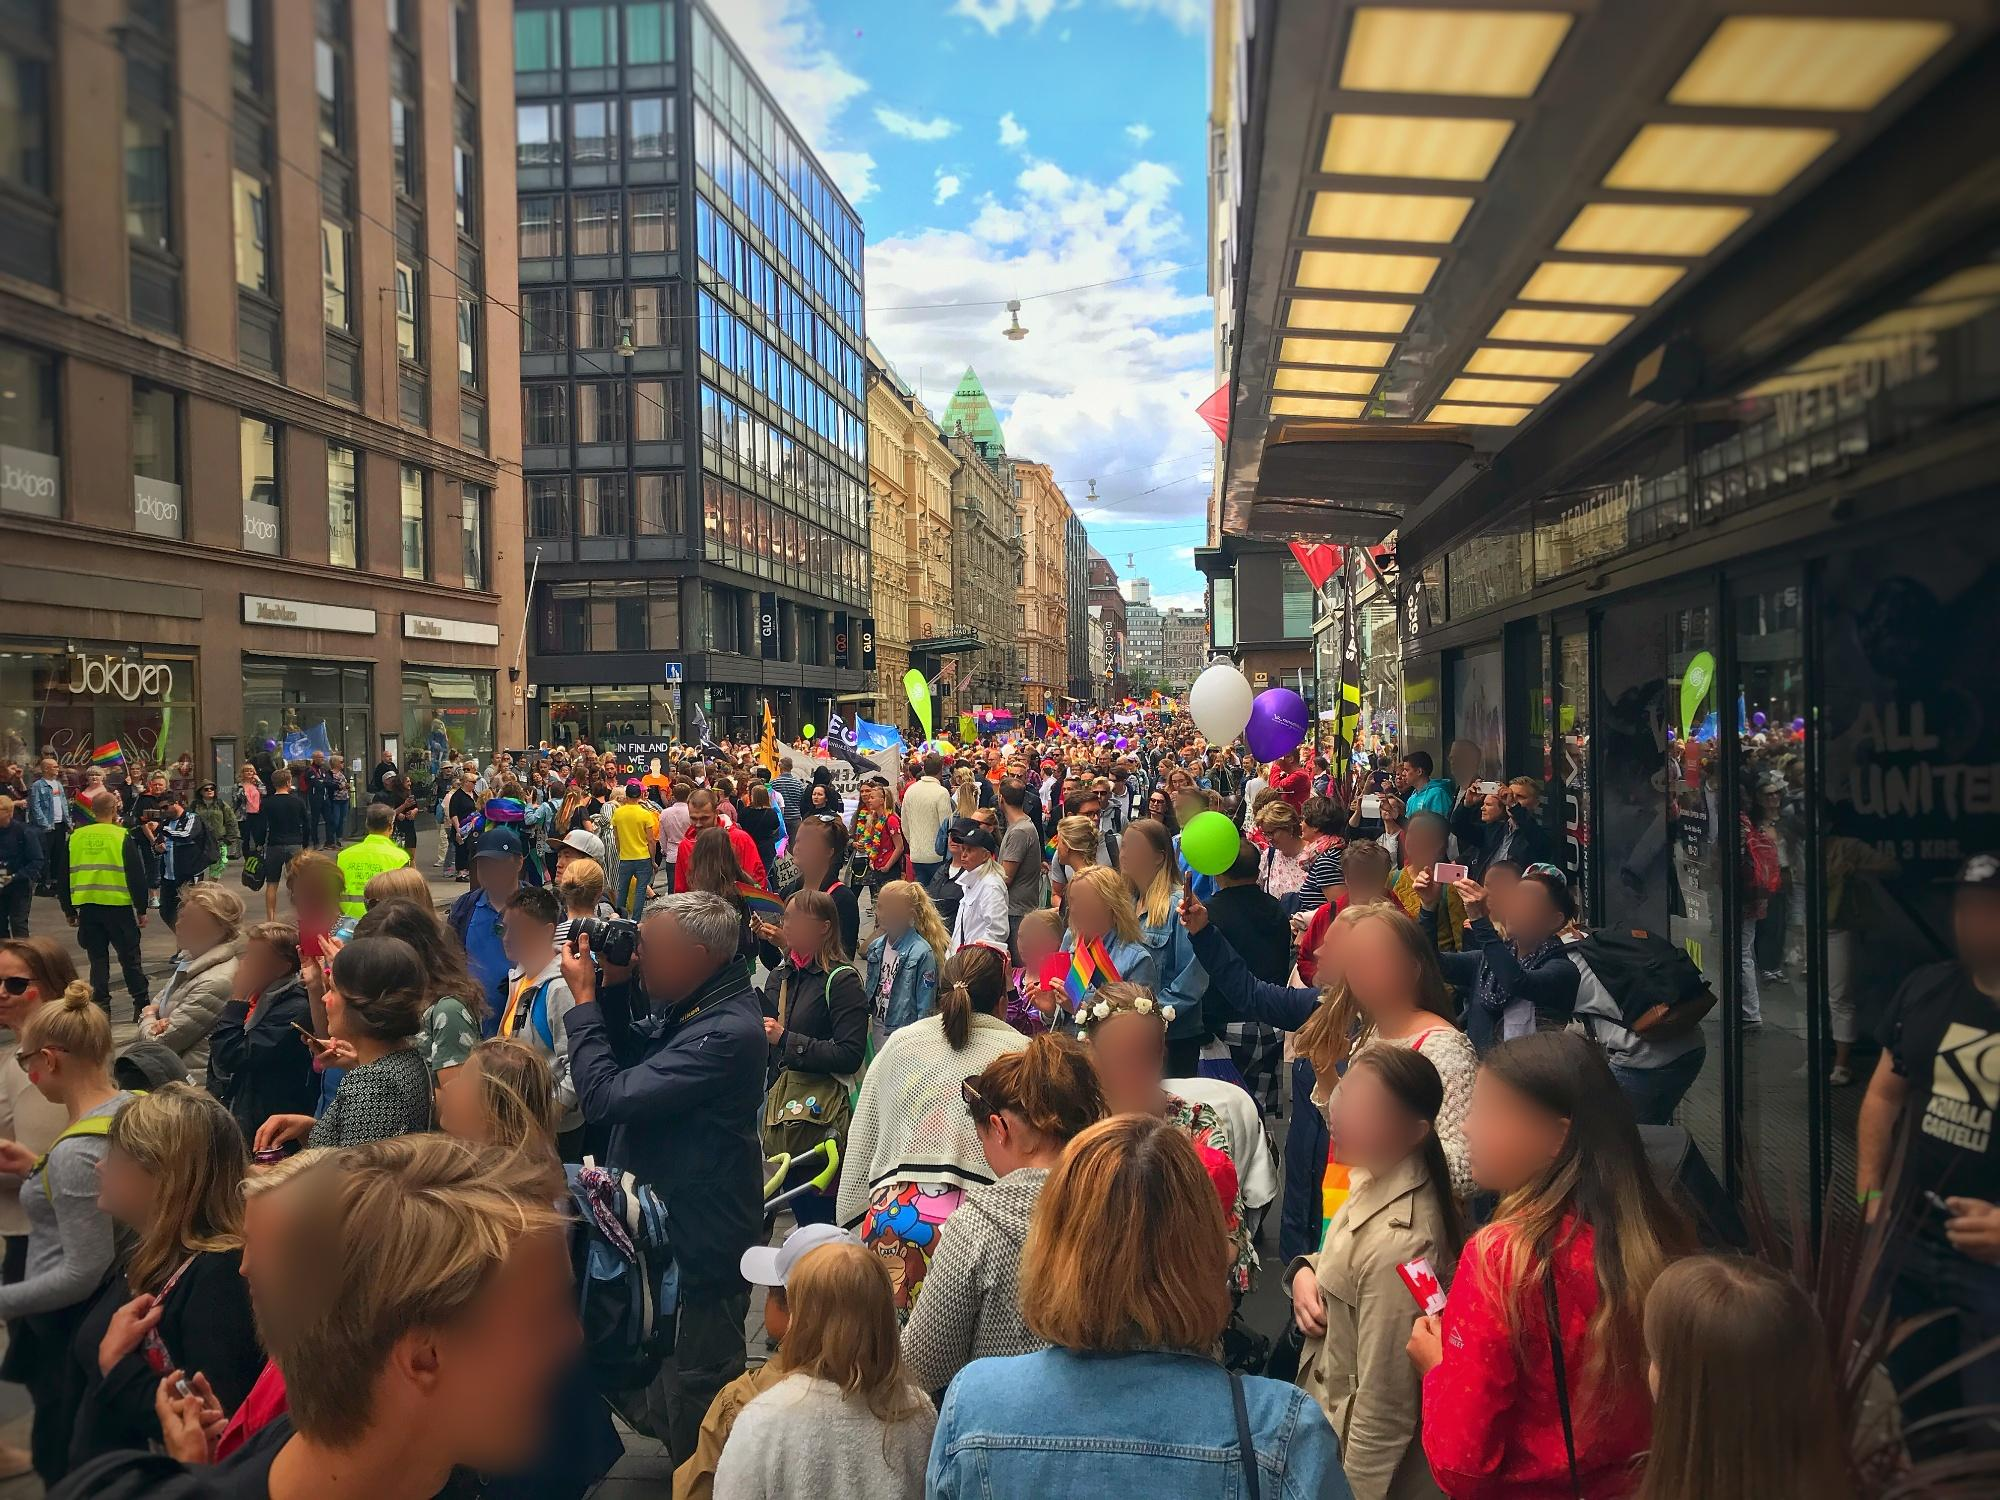Imagine a hidden story behind this parade that involves a tiny mythical creature living in the city. What could the story be? In the heart of Helsinki, an ancient mythical creature called a 'Lumi' has existed for centuries, unseen by the human eye but always present in the city's festivities. The Lumi, a tiny sprite made of frost and light, thrives on the joy and energy of celebrations. Each year, during the grand parade, the collective happiness of the city awakens the Lumi who, in turn, enhances the festive atmosphere with subtle magic, making the balloons float a little higher and the colors glow a tad brighter. Unbeknownst to the people, the Lumi's enchanted touch is what transforms the parade into an unforgettable experience, leaving a lingering sense of wonder in the hearts of all who attend. 